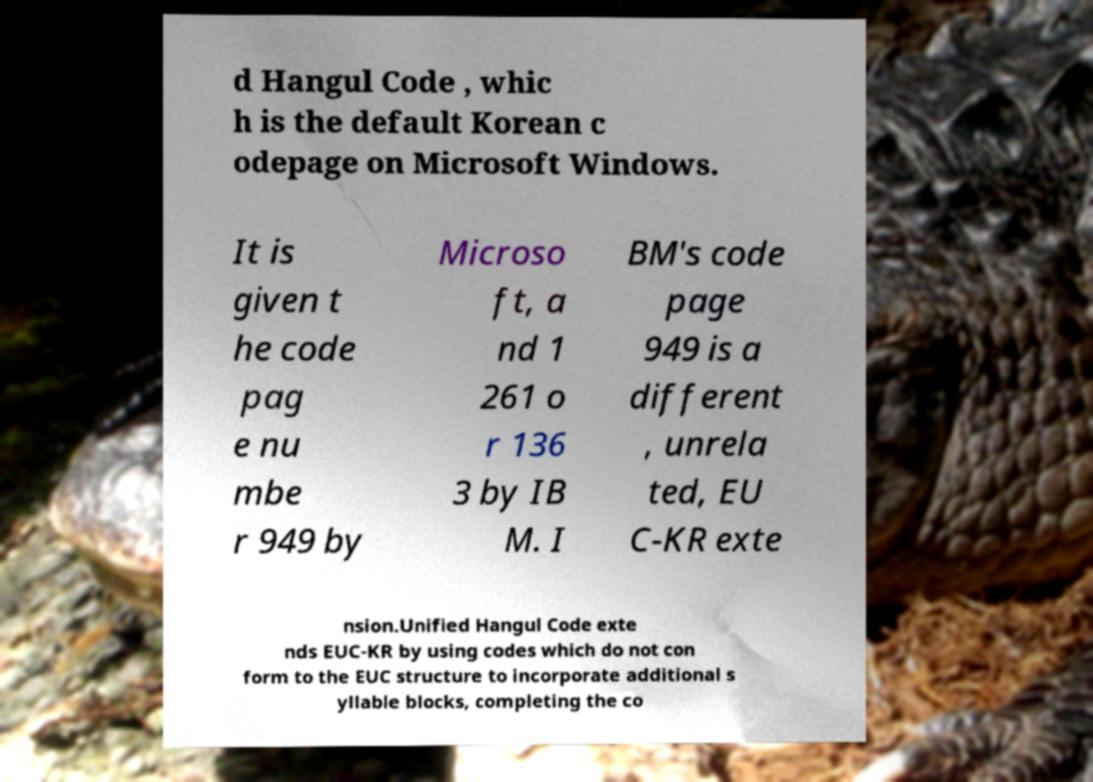Can you accurately transcribe the text from the provided image for me? d Hangul Code , whic h is the default Korean c odepage on Microsoft Windows. It is given t he code pag e nu mbe r 949 by Microso ft, a nd 1 261 o r 136 3 by IB M. I BM's code page 949 is a different , unrela ted, EU C-KR exte nsion.Unified Hangul Code exte nds EUC-KR by using codes which do not con form to the EUC structure to incorporate additional s yllable blocks, completing the co 